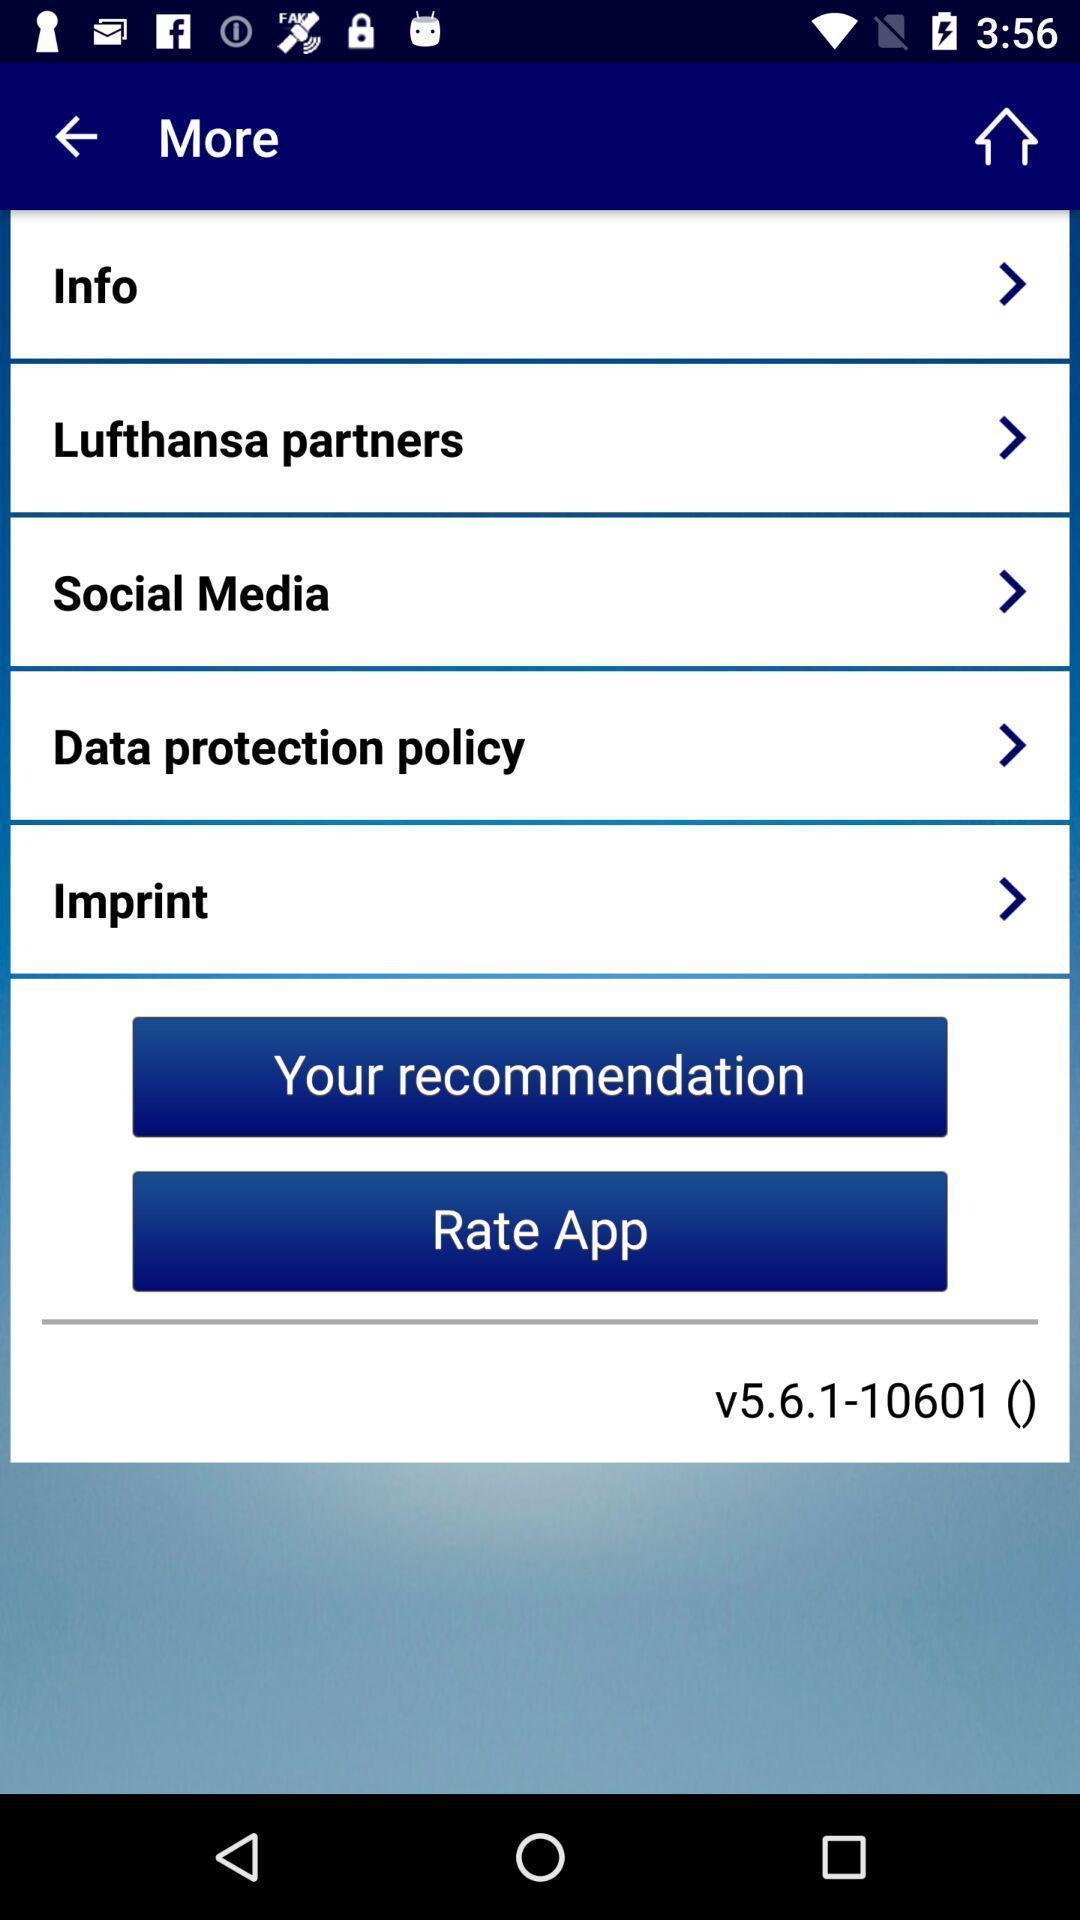Please provide a description for this image. Screen displaying multiple options in a flight booking application. 